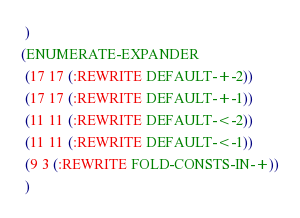Convert code to text. <code><loc_0><loc_0><loc_500><loc_500><_Lisp_> )
(ENUMERATE-EXPANDER
 (17 17 (:REWRITE DEFAULT-+-2))
 (17 17 (:REWRITE DEFAULT-+-1))
 (11 11 (:REWRITE DEFAULT-<-2))
 (11 11 (:REWRITE DEFAULT-<-1))
 (9 3 (:REWRITE FOLD-CONSTS-IN-+))
 )
</code> 